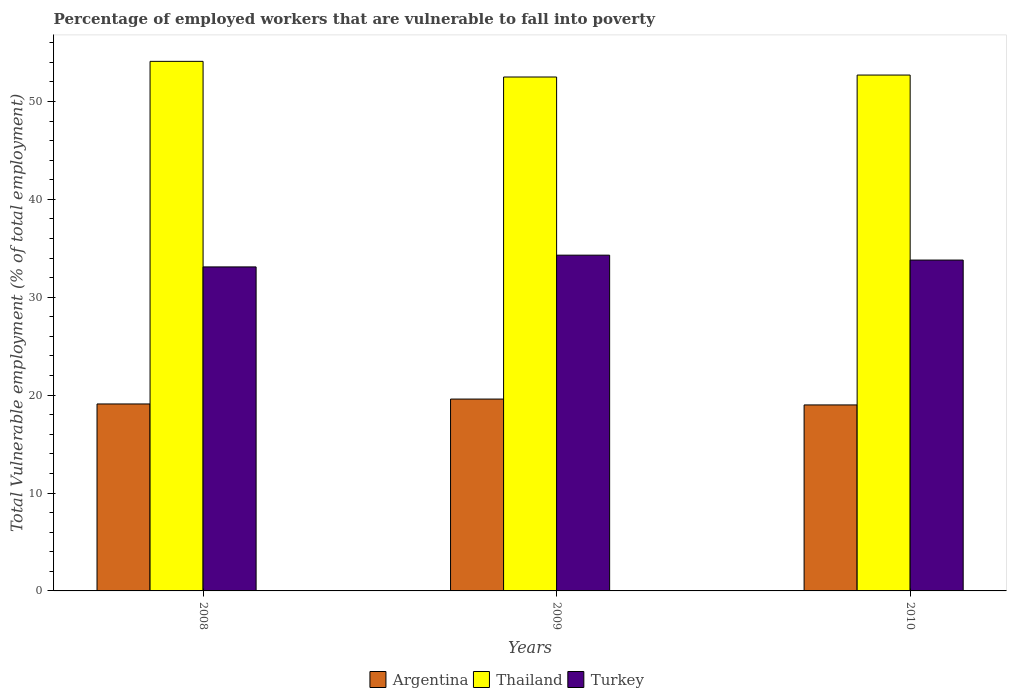How many different coloured bars are there?
Make the answer very short. 3. What is the label of the 1st group of bars from the left?
Ensure brevity in your answer.  2008. In how many cases, is the number of bars for a given year not equal to the number of legend labels?
Your answer should be compact. 0. What is the percentage of employed workers who are vulnerable to fall into poverty in Thailand in 2008?
Your answer should be very brief. 54.1. Across all years, what is the maximum percentage of employed workers who are vulnerable to fall into poverty in Argentina?
Your response must be concise. 19.6. Across all years, what is the minimum percentage of employed workers who are vulnerable to fall into poverty in Turkey?
Give a very brief answer. 33.1. What is the total percentage of employed workers who are vulnerable to fall into poverty in Turkey in the graph?
Your answer should be very brief. 101.2. What is the difference between the percentage of employed workers who are vulnerable to fall into poverty in Turkey in 2008 and that in 2009?
Provide a short and direct response. -1.2. What is the difference between the percentage of employed workers who are vulnerable to fall into poverty in Turkey in 2008 and the percentage of employed workers who are vulnerable to fall into poverty in Argentina in 2009?
Your answer should be compact. 13.5. What is the average percentage of employed workers who are vulnerable to fall into poverty in Turkey per year?
Ensure brevity in your answer.  33.73. In the year 2008, what is the difference between the percentage of employed workers who are vulnerable to fall into poverty in Turkey and percentage of employed workers who are vulnerable to fall into poverty in Thailand?
Provide a succinct answer. -21. What is the ratio of the percentage of employed workers who are vulnerable to fall into poverty in Argentina in 2009 to that in 2010?
Provide a short and direct response. 1.03. Is the percentage of employed workers who are vulnerable to fall into poverty in Argentina in 2008 less than that in 2009?
Offer a terse response. Yes. Is the difference between the percentage of employed workers who are vulnerable to fall into poverty in Turkey in 2009 and 2010 greater than the difference between the percentage of employed workers who are vulnerable to fall into poverty in Thailand in 2009 and 2010?
Make the answer very short. Yes. What is the difference between the highest and the second highest percentage of employed workers who are vulnerable to fall into poverty in Turkey?
Keep it short and to the point. 0.5. What is the difference between the highest and the lowest percentage of employed workers who are vulnerable to fall into poverty in Thailand?
Give a very brief answer. 1.6. In how many years, is the percentage of employed workers who are vulnerable to fall into poverty in Thailand greater than the average percentage of employed workers who are vulnerable to fall into poverty in Thailand taken over all years?
Provide a succinct answer. 1. What does the 2nd bar from the right in 2009 represents?
Give a very brief answer. Thailand. Is it the case that in every year, the sum of the percentage of employed workers who are vulnerable to fall into poverty in Turkey and percentage of employed workers who are vulnerable to fall into poverty in Argentina is greater than the percentage of employed workers who are vulnerable to fall into poverty in Thailand?
Make the answer very short. No. How many years are there in the graph?
Offer a very short reply. 3. What is the difference between two consecutive major ticks on the Y-axis?
Provide a succinct answer. 10. Are the values on the major ticks of Y-axis written in scientific E-notation?
Give a very brief answer. No. Does the graph contain any zero values?
Offer a terse response. No. Where does the legend appear in the graph?
Ensure brevity in your answer.  Bottom center. How many legend labels are there?
Offer a terse response. 3. How are the legend labels stacked?
Your response must be concise. Horizontal. What is the title of the graph?
Make the answer very short. Percentage of employed workers that are vulnerable to fall into poverty. Does "Armenia" appear as one of the legend labels in the graph?
Offer a terse response. No. What is the label or title of the Y-axis?
Make the answer very short. Total Vulnerable employment (% of total employment). What is the Total Vulnerable employment (% of total employment) of Argentina in 2008?
Give a very brief answer. 19.1. What is the Total Vulnerable employment (% of total employment) in Thailand in 2008?
Ensure brevity in your answer.  54.1. What is the Total Vulnerable employment (% of total employment) of Turkey in 2008?
Ensure brevity in your answer.  33.1. What is the Total Vulnerable employment (% of total employment) in Argentina in 2009?
Your answer should be very brief. 19.6. What is the Total Vulnerable employment (% of total employment) of Thailand in 2009?
Offer a very short reply. 52.5. What is the Total Vulnerable employment (% of total employment) of Turkey in 2009?
Provide a short and direct response. 34.3. What is the Total Vulnerable employment (% of total employment) in Thailand in 2010?
Offer a terse response. 52.7. What is the Total Vulnerable employment (% of total employment) of Turkey in 2010?
Provide a short and direct response. 33.8. Across all years, what is the maximum Total Vulnerable employment (% of total employment) in Argentina?
Your answer should be very brief. 19.6. Across all years, what is the maximum Total Vulnerable employment (% of total employment) of Thailand?
Your answer should be very brief. 54.1. Across all years, what is the maximum Total Vulnerable employment (% of total employment) in Turkey?
Offer a very short reply. 34.3. Across all years, what is the minimum Total Vulnerable employment (% of total employment) of Thailand?
Provide a succinct answer. 52.5. Across all years, what is the minimum Total Vulnerable employment (% of total employment) in Turkey?
Make the answer very short. 33.1. What is the total Total Vulnerable employment (% of total employment) of Argentina in the graph?
Your response must be concise. 57.7. What is the total Total Vulnerable employment (% of total employment) of Thailand in the graph?
Offer a very short reply. 159.3. What is the total Total Vulnerable employment (% of total employment) in Turkey in the graph?
Give a very brief answer. 101.2. What is the difference between the Total Vulnerable employment (% of total employment) of Argentina in 2008 and that in 2009?
Provide a succinct answer. -0.5. What is the difference between the Total Vulnerable employment (% of total employment) in Turkey in 2008 and that in 2009?
Keep it short and to the point. -1.2. What is the difference between the Total Vulnerable employment (% of total employment) in Argentina in 2008 and that in 2010?
Ensure brevity in your answer.  0.1. What is the difference between the Total Vulnerable employment (% of total employment) in Thailand in 2008 and that in 2010?
Give a very brief answer. 1.4. What is the difference between the Total Vulnerable employment (% of total employment) of Turkey in 2008 and that in 2010?
Ensure brevity in your answer.  -0.7. What is the difference between the Total Vulnerable employment (% of total employment) of Argentina in 2009 and that in 2010?
Your answer should be compact. 0.6. What is the difference between the Total Vulnerable employment (% of total employment) of Turkey in 2009 and that in 2010?
Your answer should be very brief. 0.5. What is the difference between the Total Vulnerable employment (% of total employment) in Argentina in 2008 and the Total Vulnerable employment (% of total employment) in Thailand in 2009?
Give a very brief answer. -33.4. What is the difference between the Total Vulnerable employment (% of total employment) of Argentina in 2008 and the Total Vulnerable employment (% of total employment) of Turkey in 2009?
Offer a terse response. -15.2. What is the difference between the Total Vulnerable employment (% of total employment) in Thailand in 2008 and the Total Vulnerable employment (% of total employment) in Turkey in 2009?
Ensure brevity in your answer.  19.8. What is the difference between the Total Vulnerable employment (% of total employment) in Argentina in 2008 and the Total Vulnerable employment (% of total employment) in Thailand in 2010?
Provide a short and direct response. -33.6. What is the difference between the Total Vulnerable employment (% of total employment) of Argentina in 2008 and the Total Vulnerable employment (% of total employment) of Turkey in 2010?
Your answer should be compact. -14.7. What is the difference between the Total Vulnerable employment (% of total employment) of Thailand in 2008 and the Total Vulnerable employment (% of total employment) of Turkey in 2010?
Give a very brief answer. 20.3. What is the difference between the Total Vulnerable employment (% of total employment) in Argentina in 2009 and the Total Vulnerable employment (% of total employment) in Thailand in 2010?
Your response must be concise. -33.1. What is the difference between the Total Vulnerable employment (% of total employment) in Argentina in 2009 and the Total Vulnerable employment (% of total employment) in Turkey in 2010?
Give a very brief answer. -14.2. What is the average Total Vulnerable employment (% of total employment) in Argentina per year?
Provide a short and direct response. 19.23. What is the average Total Vulnerable employment (% of total employment) in Thailand per year?
Provide a succinct answer. 53.1. What is the average Total Vulnerable employment (% of total employment) in Turkey per year?
Your answer should be compact. 33.73. In the year 2008, what is the difference between the Total Vulnerable employment (% of total employment) of Argentina and Total Vulnerable employment (% of total employment) of Thailand?
Your response must be concise. -35. In the year 2008, what is the difference between the Total Vulnerable employment (% of total employment) in Argentina and Total Vulnerable employment (% of total employment) in Turkey?
Offer a terse response. -14. In the year 2009, what is the difference between the Total Vulnerable employment (% of total employment) of Argentina and Total Vulnerable employment (% of total employment) of Thailand?
Provide a short and direct response. -32.9. In the year 2009, what is the difference between the Total Vulnerable employment (% of total employment) of Argentina and Total Vulnerable employment (% of total employment) of Turkey?
Make the answer very short. -14.7. In the year 2009, what is the difference between the Total Vulnerable employment (% of total employment) of Thailand and Total Vulnerable employment (% of total employment) of Turkey?
Keep it short and to the point. 18.2. In the year 2010, what is the difference between the Total Vulnerable employment (% of total employment) in Argentina and Total Vulnerable employment (% of total employment) in Thailand?
Provide a succinct answer. -33.7. In the year 2010, what is the difference between the Total Vulnerable employment (% of total employment) in Argentina and Total Vulnerable employment (% of total employment) in Turkey?
Your answer should be very brief. -14.8. In the year 2010, what is the difference between the Total Vulnerable employment (% of total employment) of Thailand and Total Vulnerable employment (% of total employment) of Turkey?
Your answer should be very brief. 18.9. What is the ratio of the Total Vulnerable employment (% of total employment) of Argentina in 2008 to that in 2009?
Your answer should be very brief. 0.97. What is the ratio of the Total Vulnerable employment (% of total employment) in Thailand in 2008 to that in 2009?
Provide a short and direct response. 1.03. What is the ratio of the Total Vulnerable employment (% of total employment) of Turkey in 2008 to that in 2009?
Your response must be concise. 0.96. What is the ratio of the Total Vulnerable employment (% of total employment) in Thailand in 2008 to that in 2010?
Provide a succinct answer. 1.03. What is the ratio of the Total Vulnerable employment (% of total employment) in Turkey in 2008 to that in 2010?
Your answer should be very brief. 0.98. What is the ratio of the Total Vulnerable employment (% of total employment) in Argentina in 2009 to that in 2010?
Provide a short and direct response. 1.03. What is the ratio of the Total Vulnerable employment (% of total employment) in Thailand in 2009 to that in 2010?
Make the answer very short. 1. What is the ratio of the Total Vulnerable employment (% of total employment) of Turkey in 2009 to that in 2010?
Make the answer very short. 1.01. What is the difference between the highest and the second highest Total Vulnerable employment (% of total employment) of Argentina?
Provide a short and direct response. 0.5. What is the difference between the highest and the lowest Total Vulnerable employment (% of total employment) in Turkey?
Your answer should be very brief. 1.2. 